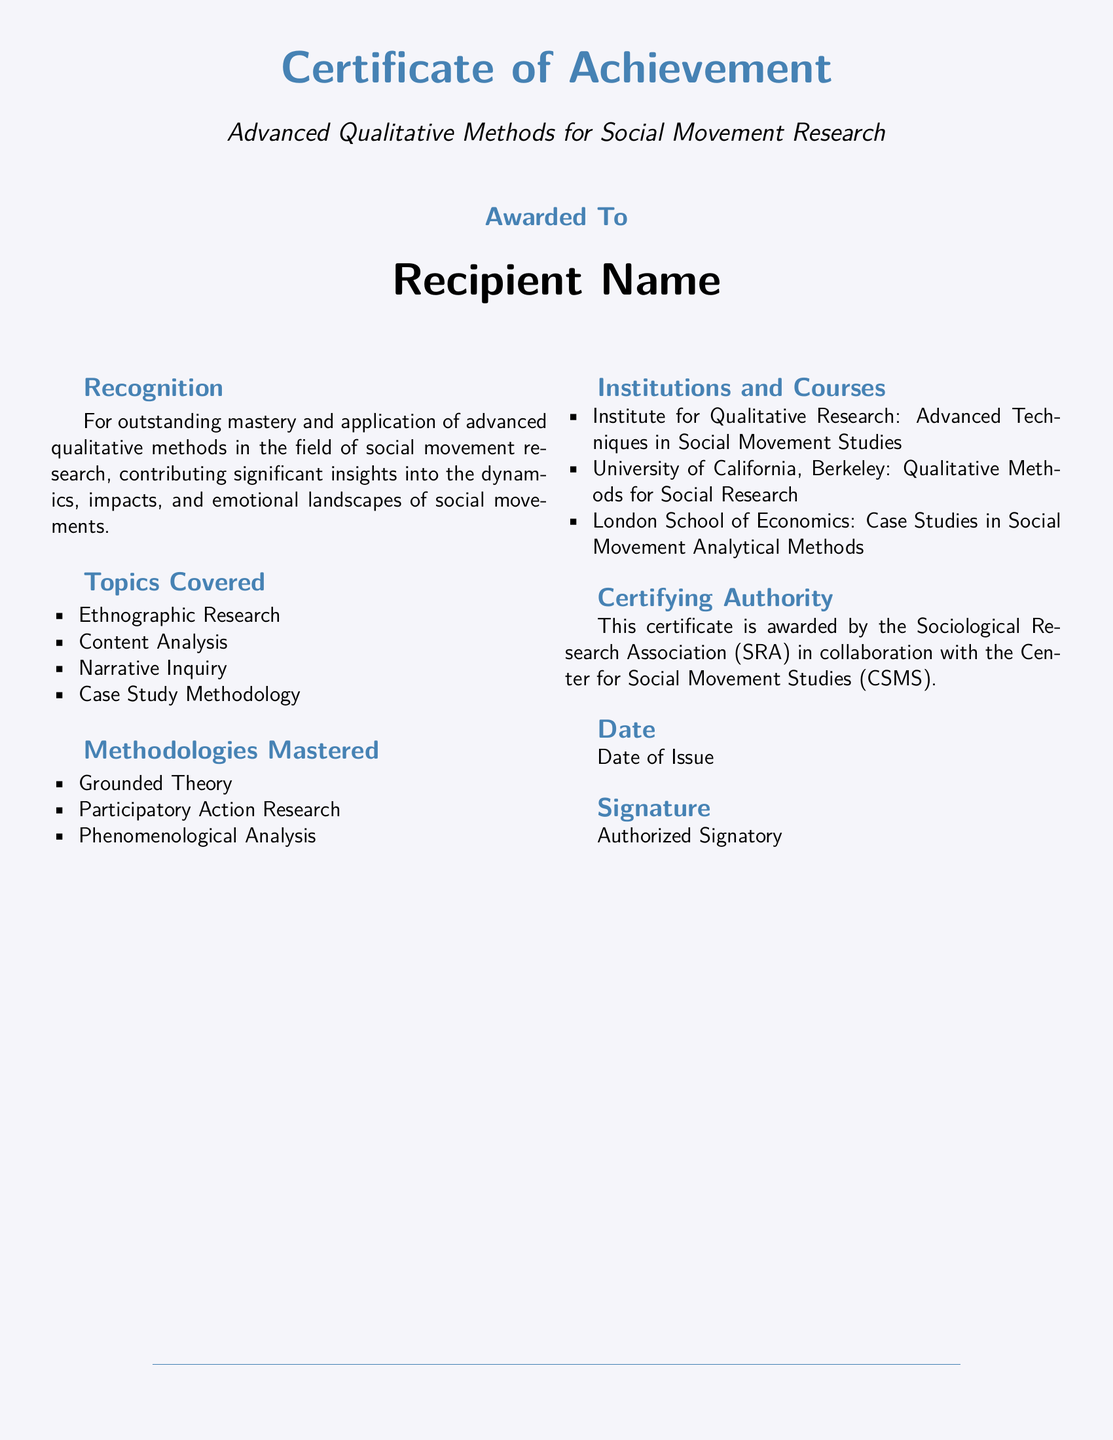What is the title of the certificate? The title of the certificate is prominently displayed in a large font near the top of the document.
Answer: Certificate of Achievement: Advanced Qualitative Methods for Social Movement Research Who is the certificate awarded to? The recipient's name is mentioned in a large font in the center of the document.
Answer: Recipient Name What is the certifying authority? The certifying authority is listed towards the end of the certificate, including the organizations involved.
Answer: Sociological Research Association (SRA) and Center for Social Movement Studies (CSMS) Which research methodologies are mastered according to the certificate? The methodologies are listed in a section specifically dedicated to what has been mastered.
Answer: Grounded Theory, Participatory Action Research, Phenomenological Analysis What is the date of issue? The date of issue is specified at the end of the document, but it is represented as a placeholder.
Answer: Date of Issue Give one topic covered in the course. Topics covered are listed in a bullet point format within the document.
Answer: Ethnographic Research What are the institutions that provided courses for this certificate? The institutions are enumerated in a dedicated section of the document, highlighting the specific courses as well.
Answer: Institute for Qualitative Research, University of California, Berkeley, London School of Economics What is the color scheme of the document's background? The color of the background is described in the introductory formatting details of the document.
Answer: RGB (245,245,250) 